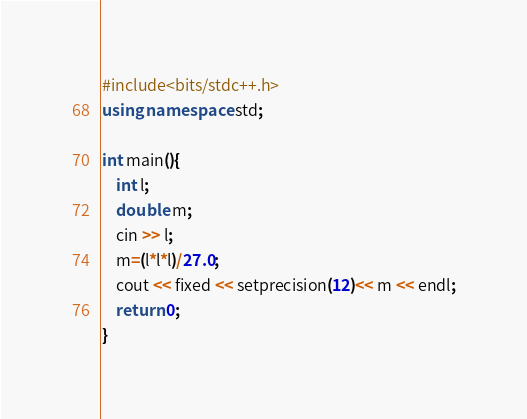<code> <loc_0><loc_0><loc_500><loc_500><_C++_>#include<bits/stdc++.h>
using namespace std;

int main(){
    int l;
    double m;
    cin >> l;
    m=(l*l*l)/27.0;
    cout << fixed << setprecision(12)<< m << endl;
    return 0;
}
</code> 